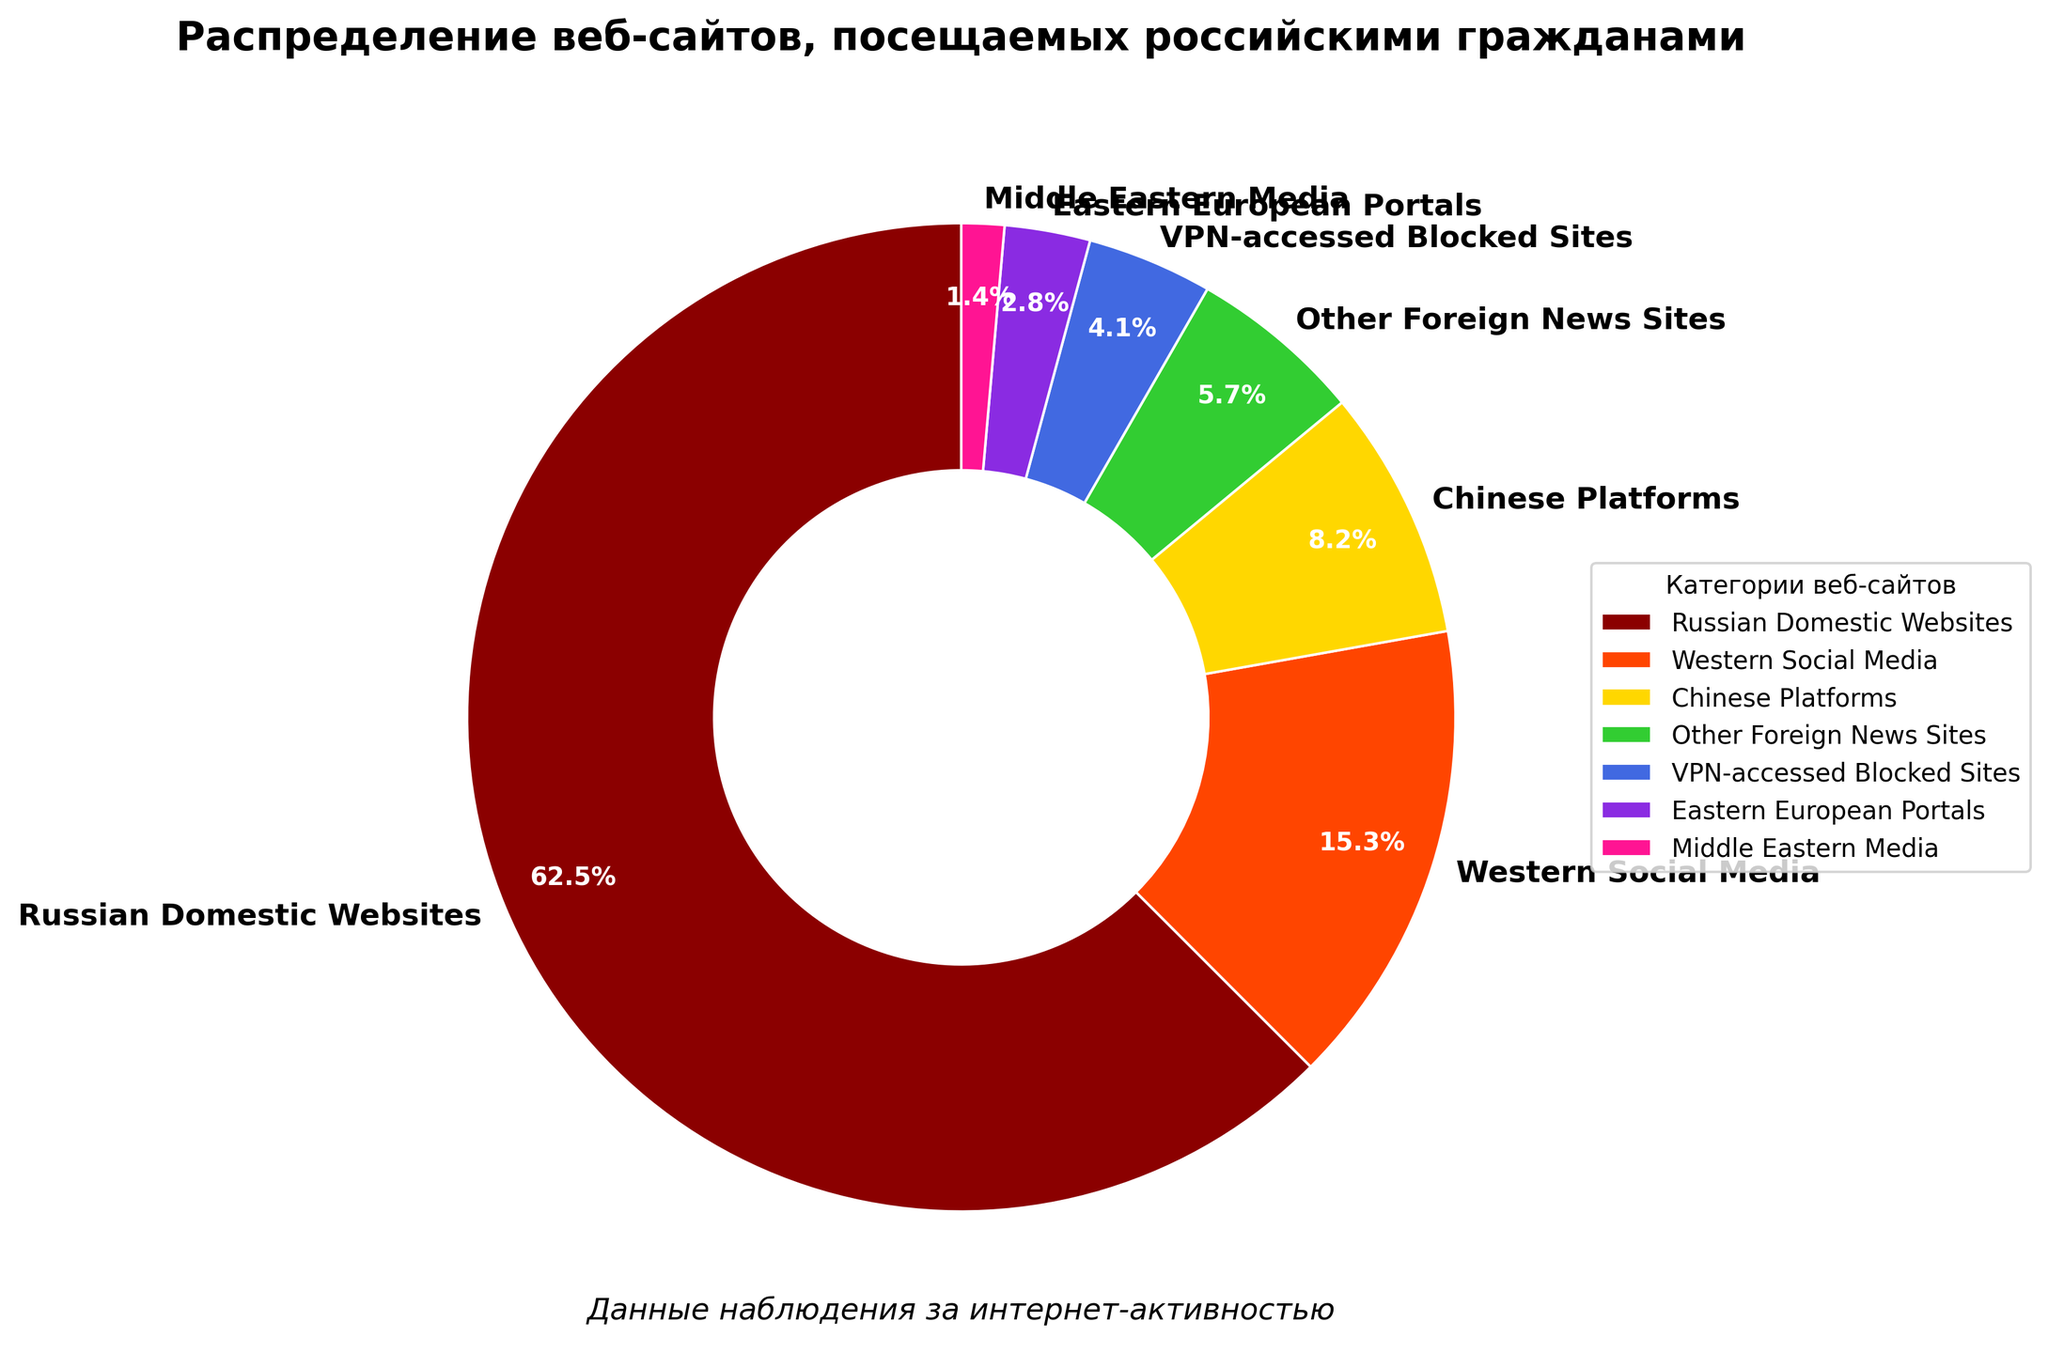Which category of websites has the largest percentage of access by Russian citizens? The figure shows the percentages of different website categories accessed. The category with the largest percentage is "Russian Domestic Websites" at 62.5%.
Answer: Russian Domestic Websites What is the combined percentage of Western Social Media and Chinese Platforms? Western Social Media accounts for 15.3% and Chinese Platforms account for 8.2%. Adding them together, 15.3 + 8.2 = 23.5%.
Answer: 23.5% How much more are Russian Domestic Websites accessed compared to Eastern European Portals? Russian Domestic Websites have a percentage of 62.5%, while Eastern European Portals have 2.8%. Subtracting these, 62.5 - 2.8 = 59.7%.
Answer: 59.7% Which categories of websites have a percentage below 5%? From the figure, the categories with percentages below 5% are VPN-accessed Blocked Sites (4.1%), Eastern European Portals (2.8%), and Middle Eastern Media (1.4%).
Answer: VPN-accessed Blocked Sites, Eastern European Portals, Middle Eastern Media Are Western Social Media and Eastern European Portals combined accessed more than Chinese Platforms? Western Social Media has 15.3% and Eastern European Portals have 2.8%. Adding them, the total is 15.3 + 2.8 = 18.1%. Chinese Platforms have 8.2%. Since 18.1% is greater than 8.2%, the combined access is more.
Answer: Yes What is the difference in access percentage between Western Social Media and Other Foreign News Sites? Western Social Media has 15.3% and Other Foreign News Sites have 5.7%. Subtracting them, 15.3 - 5.7 = 9.6%.
Answer: 9.6% Which category has the least percentage of access? The figure shows that the category with the least access is "Middle Eastern Media" at 1.4%.
Answer: Middle Eastern Media How does the percentage of access to VPN-accessed Blocked Sites compare to Chinese Platforms? VPN-accessed Blocked Sites have a percentage of 4.1%, whereas Chinese Platforms have 8.2%. Since 4.1% is less than 8.2%, VPN-accessed Blocked Sites are accessed less.
Answer: Less 